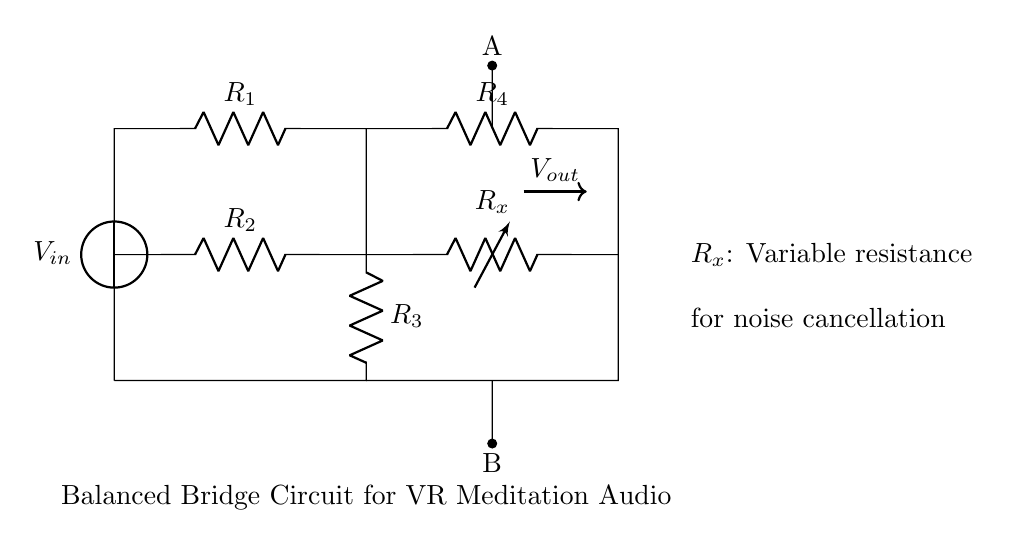What is the input voltage of the circuit? The input voltage is denoted as V_in, which is the source voltage connected at the left side of the circuit.
Answer: V_in What is the purpose of R_x in the circuit? R_x is labeled as a variable resistance that adjusts for noise cancellation, allowing for fine-tuning of the circuit to mitigate unwanted noise in audio systems.
Answer: Noise cancellation How many resistors are in this balanced bridge circuit? There are four resistors labeled R_1, R_2, R_3, and R_4 in the circuit, all contributing to the bridge's operation.
Answer: Four What components form the output voltage connection? The output voltage, denoted as V_out, is connected from point A to point B in the circuit, which is determined by the configuration of the resistors.
Answer: A and B What is the role of the balanced bridge circuit in VR meditation? The balanced bridge circuit is designed to minimize noise in audio systems, enhancing the clarity and quality of guided meditation experiences in virtual reality applications.
Answer: Minimize noise What type of circuit is shown here? The circuit displayed is a balanced bridge circuit, which is characterized by its four resistors arranged in a specific configuration to achieve balance.
Answer: Balanced bridge circuit What adjustment can be made to R_x? R_x is a variable resistor, which means it can be adjusted to different resistance values to optimize the noise cancellation effect of the circuit.
Answer: Adjust resistance 